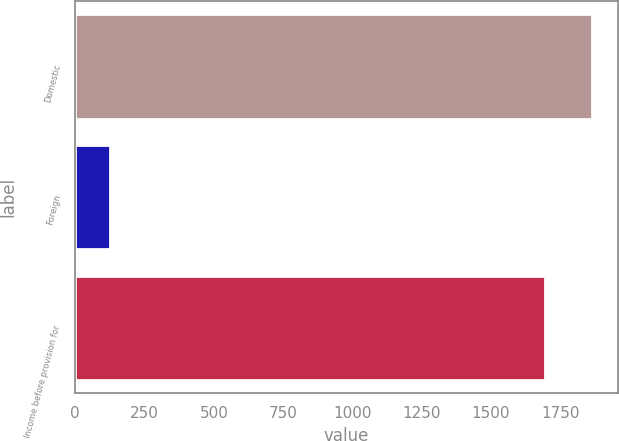<chart> <loc_0><loc_0><loc_500><loc_500><bar_chart><fcel>Domestic<fcel>Foreign<fcel>Income before provision for<nl><fcel>1864.5<fcel>124<fcel>1695<nl></chart> 